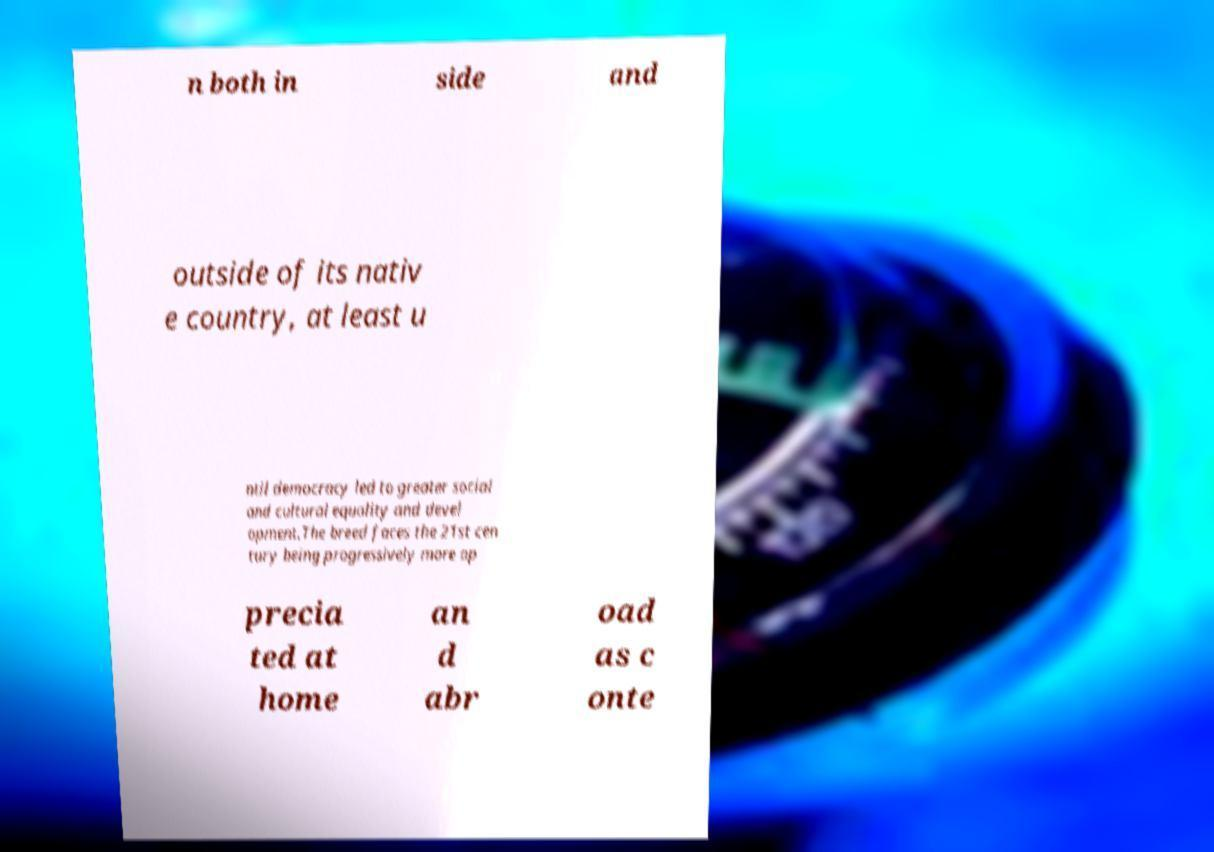Could you assist in decoding the text presented in this image and type it out clearly? n both in side and outside of its nativ e country, at least u ntil democracy led to greater social and cultural equality and devel opment.The breed faces the 21st cen tury being progressively more ap precia ted at home an d abr oad as c onte 